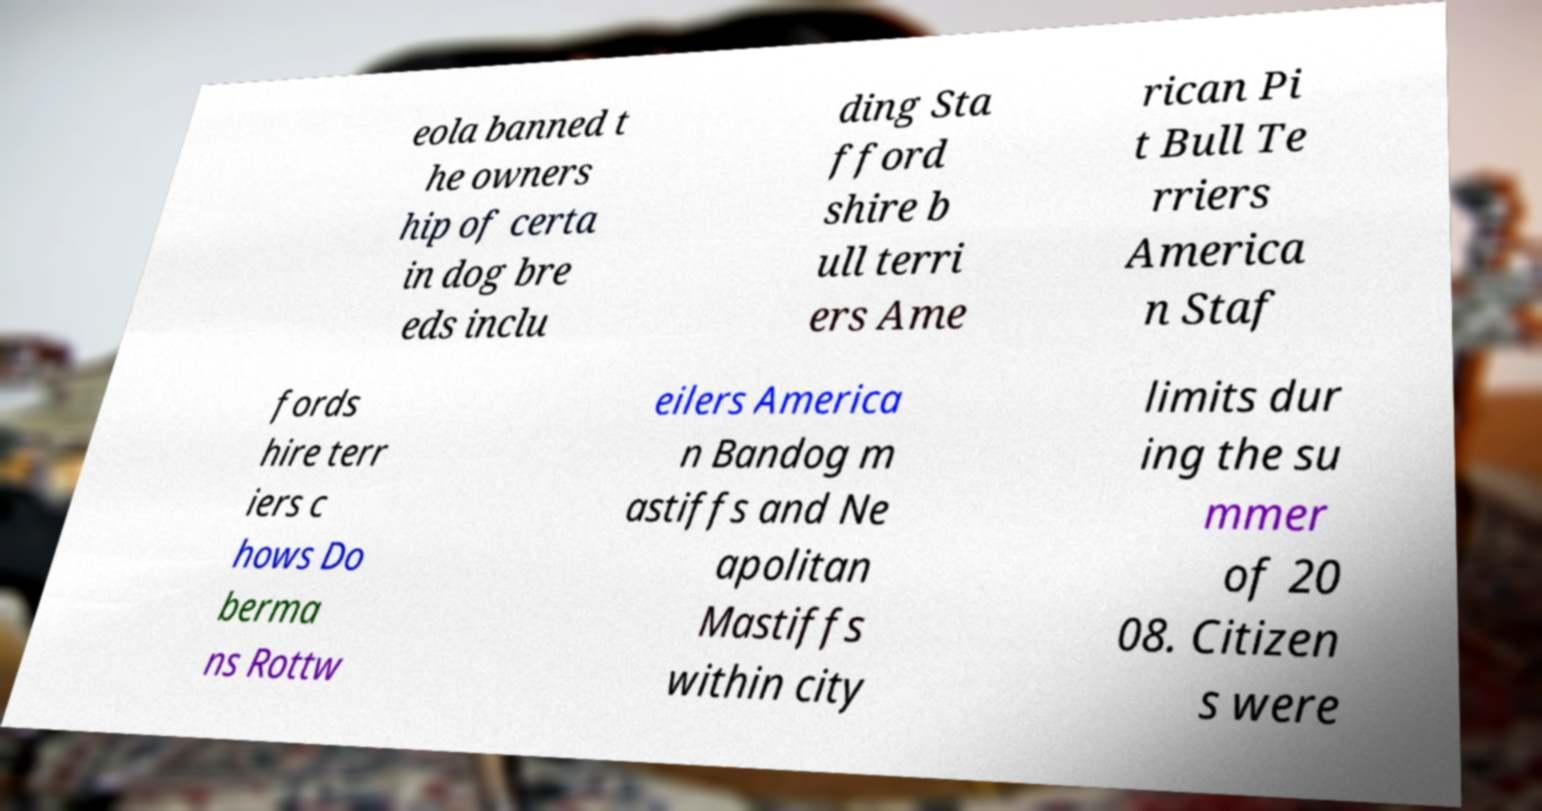Please read and relay the text visible in this image. What does it say? eola banned t he owners hip of certa in dog bre eds inclu ding Sta fford shire b ull terri ers Ame rican Pi t Bull Te rriers America n Staf fords hire terr iers c hows Do berma ns Rottw eilers America n Bandog m astiffs and Ne apolitan Mastiffs within city limits dur ing the su mmer of 20 08. Citizen s were 